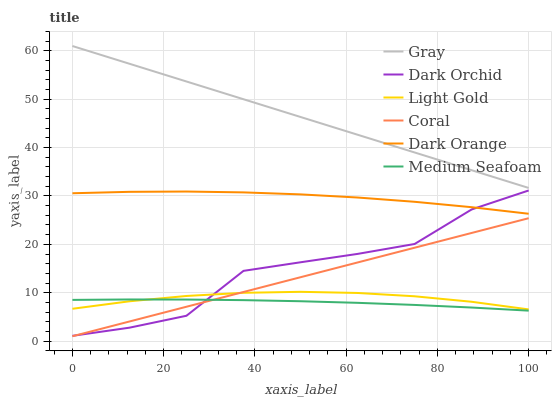Does Medium Seafoam have the minimum area under the curve?
Answer yes or no. Yes. Does Gray have the maximum area under the curve?
Answer yes or no. Yes. Does Dark Orange have the minimum area under the curve?
Answer yes or no. No. Does Dark Orange have the maximum area under the curve?
Answer yes or no. No. Is Coral the smoothest?
Answer yes or no. Yes. Is Dark Orchid the roughest?
Answer yes or no. Yes. Is Dark Orange the smoothest?
Answer yes or no. No. Is Dark Orange the roughest?
Answer yes or no. No. Does Coral have the lowest value?
Answer yes or no. Yes. Does Dark Orange have the lowest value?
Answer yes or no. No. Does Gray have the highest value?
Answer yes or no. Yes. Does Dark Orange have the highest value?
Answer yes or no. No. Is Dark Orchid less than Gray?
Answer yes or no. Yes. Is Gray greater than Coral?
Answer yes or no. Yes. Does Light Gold intersect Dark Orchid?
Answer yes or no. Yes. Is Light Gold less than Dark Orchid?
Answer yes or no. No. Is Light Gold greater than Dark Orchid?
Answer yes or no. No. Does Dark Orchid intersect Gray?
Answer yes or no. No. 